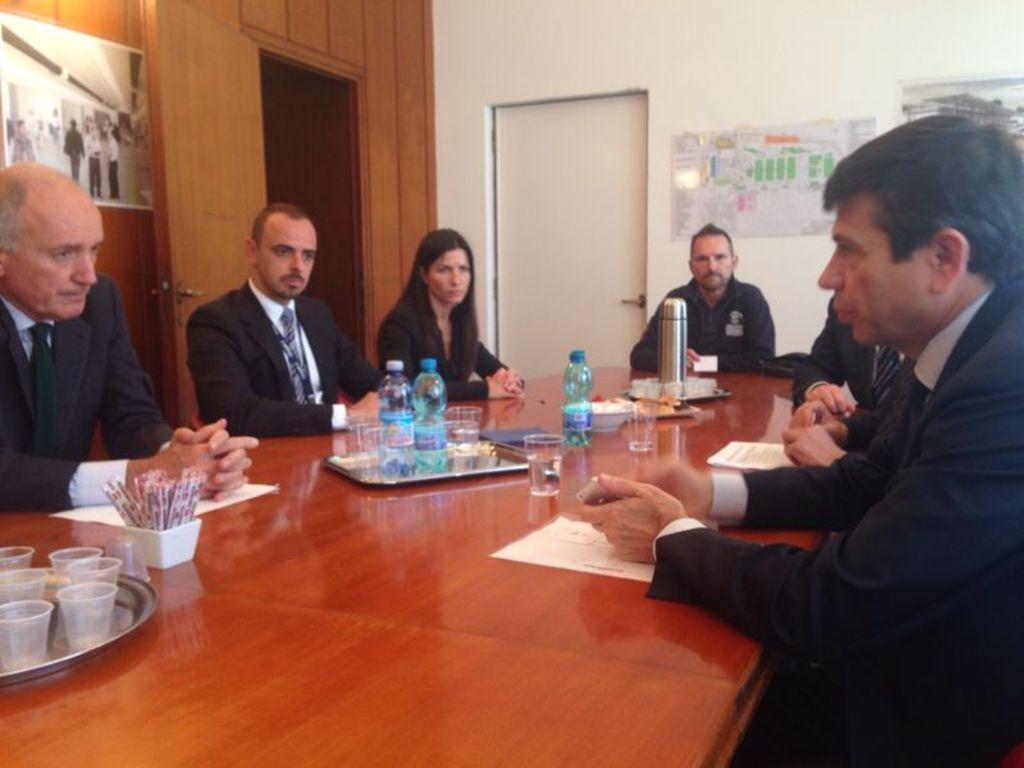Describe this image in one or two sentences. In this picture there are a group of people sitting, there have a table in front of them with some water bottles, a flask and some sugar packets is also some glasses kept on it. 